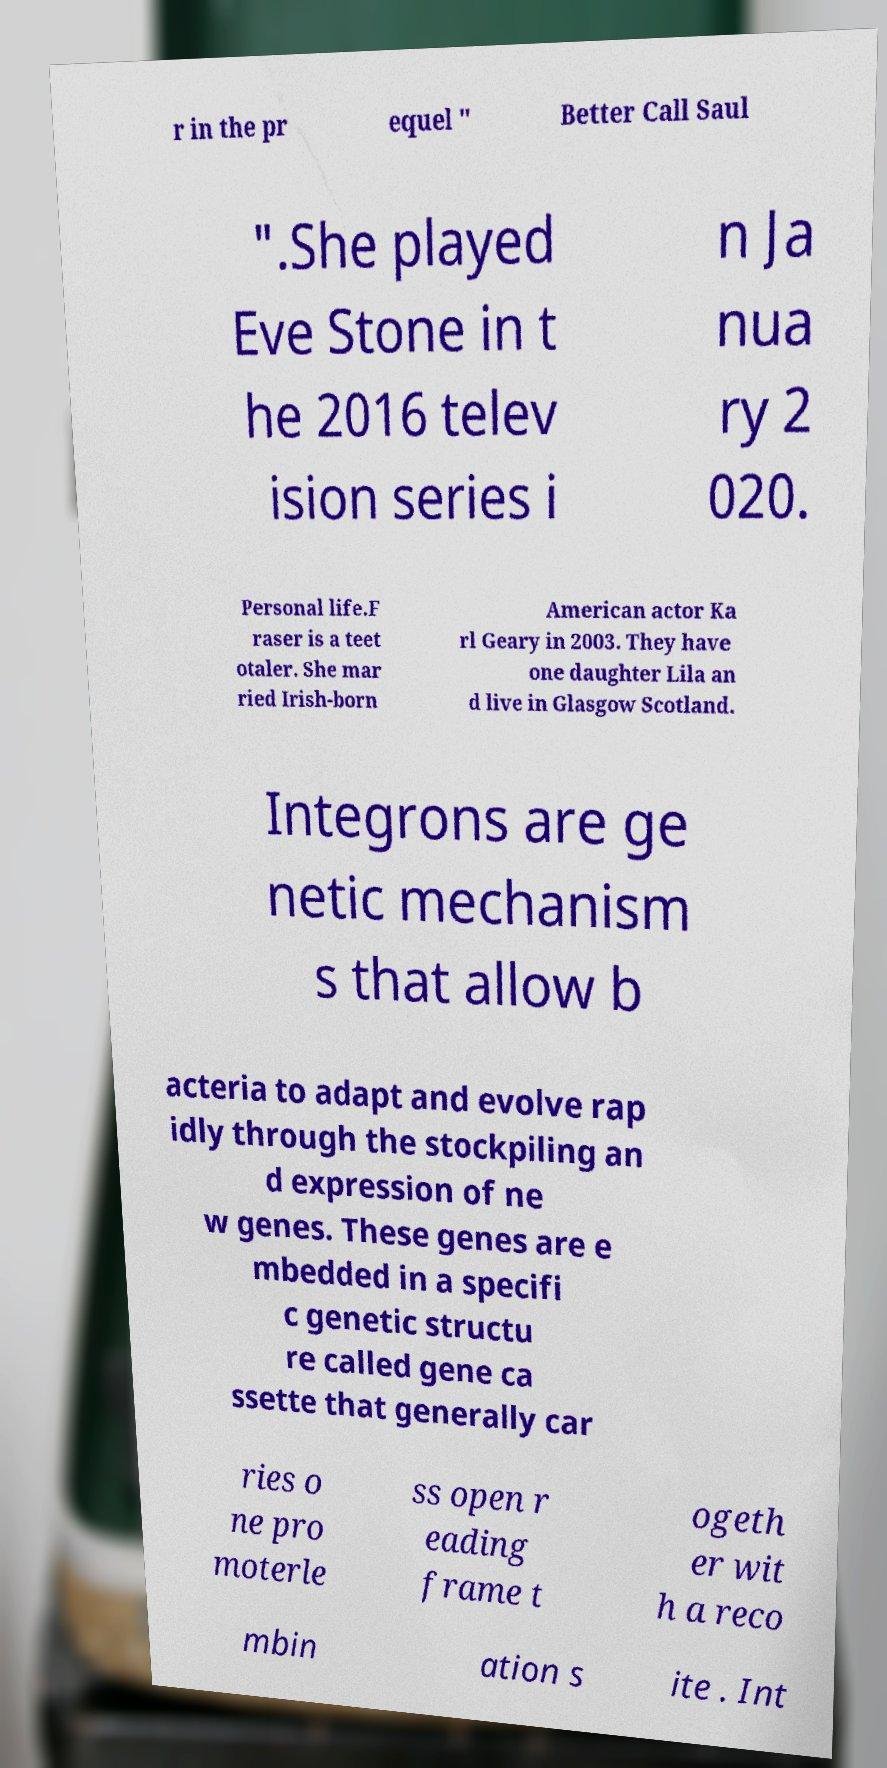Can you read and provide the text displayed in the image?This photo seems to have some interesting text. Can you extract and type it out for me? r in the pr equel " Better Call Saul ".She played Eve Stone in t he 2016 telev ision series i n Ja nua ry 2 020. Personal life.F raser is a teet otaler. She mar ried Irish-born American actor Ka rl Geary in 2003. They have one daughter Lila an d live in Glasgow Scotland. Integrons are ge netic mechanism s that allow b acteria to adapt and evolve rap idly through the stockpiling an d expression of ne w genes. These genes are e mbedded in a specifi c genetic structu re called gene ca ssette that generally car ries o ne pro moterle ss open r eading frame t ogeth er wit h a reco mbin ation s ite . Int 